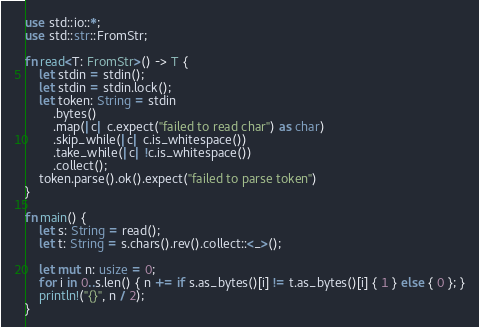Convert code to text. <code><loc_0><loc_0><loc_500><loc_500><_Rust_>use std::io::*;
use std::str::FromStr;

fn read<T: FromStr>() -> T {
    let stdin = stdin();
    let stdin = stdin.lock();
    let token: String = stdin
        .bytes()
        .map(|c| c.expect("failed to read char") as char)
        .skip_while(|c| c.is_whitespace())
        .take_while(|c| !c.is_whitespace())
        .collect();
    token.parse().ok().expect("failed to parse token")
}

fn main() {
    let s: String = read();
    let t: String = s.chars().rev().collect::<_>();

    let mut n: usize = 0;
    for i in 0..s.len() { n += if s.as_bytes()[i] != t.as_bytes()[i] { 1 } else { 0 }; }
    println!("{}", n / 2);
}</code> 